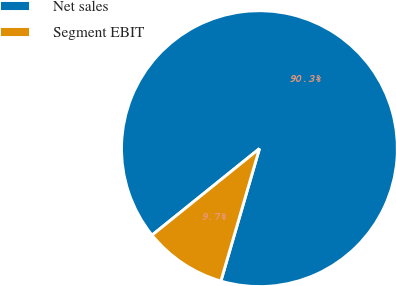<chart> <loc_0><loc_0><loc_500><loc_500><pie_chart><fcel>Net sales<fcel>Segment EBIT<nl><fcel>90.3%<fcel>9.7%<nl></chart> 